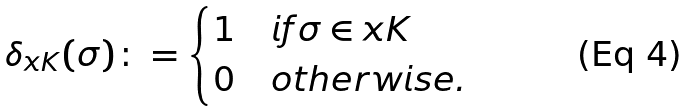<formula> <loc_0><loc_0><loc_500><loc_500>\delta _ { x K } ( \sigma ) \colon = \begin{cases} 1 & i f \sigma \in x K \\ 0 & o t h e r w i s e . \end{cases}</formula> 